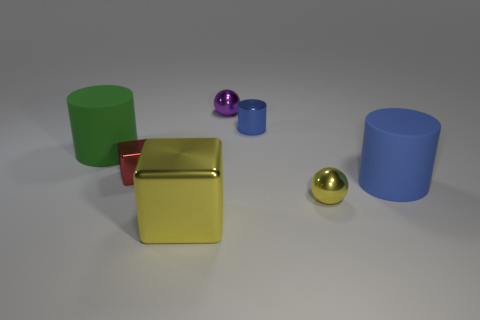Add 1 tiny spheres. How many objects exist? 8 Subtract all blocks. How many objects are left? 5 Add 3 tiny metallic objects. How many tiny metallic objects exist? 7 Subtract 0 green cubes. How many objects are left? 7 Subtract all yellow balls. Subtract all cyan metal cubes. How many objects are left? 6 Add 6 tiny red metallic blocks. How many tiny red metallic blocks are left? 7 